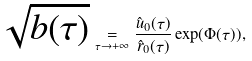<formula> <loc_0><loc_0><loc_500><loc_500>\sqrt { b ( \tau ) } \underset { \tau \to + \infty } { = } \frac { \hat { u } _ { 0 } ( \tau ) } { \hat { r } _ { 0 } ( \tau ) } \exp ( \Phi ( \tau ) ) ,</formula> 